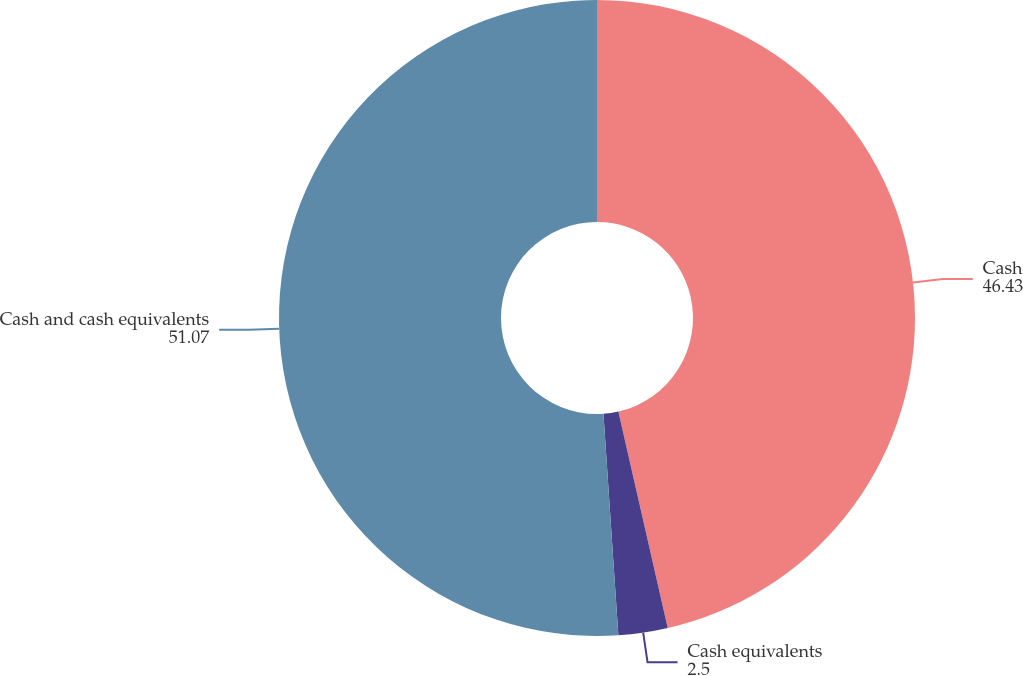<chart> <loc_0><loc_0><loc_500><loc_500><pie_chart><fcel>Cash<fcel>Cash equivalents<fcel>Cash and cash equivalents<nl><fcel>46.43%<fcel>2.5%<fcel>51.07%<nl></chart> 